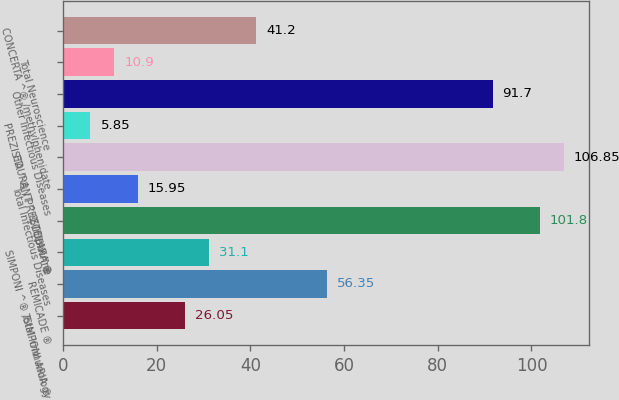Convert chart. <chart><loc_0><loc_0><loc_500><loc_500><bar_chart><fcel>Total Immunology<fcel>REMICADE ®<fcel>SIMPONI ^® /SIMPONI ARIA ®<fcel>STELARA ®<fcel>Total Infectious Diseases<fcel>EDURANT ^® /rilpivirine<fcel>PREZISTA ^® / PREZCOBIX ^®<fcel>Other Infectious Diseases<fcel>Total Neuroscience<fcel>CONCERTA ^® /methylphenidate<nl><fcel>26.05<fcel>56.35<fcel>31.1<fcel>101.8<fcel>15.95<fcel>106.85<fcel>5.85<fcel>91.7<fcel>10.9<fcel>41.2<nl></chart> 